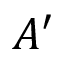<formula> <loc_0><loc_0><loc_500><loc_500>A ^ { \prime }</formula> 